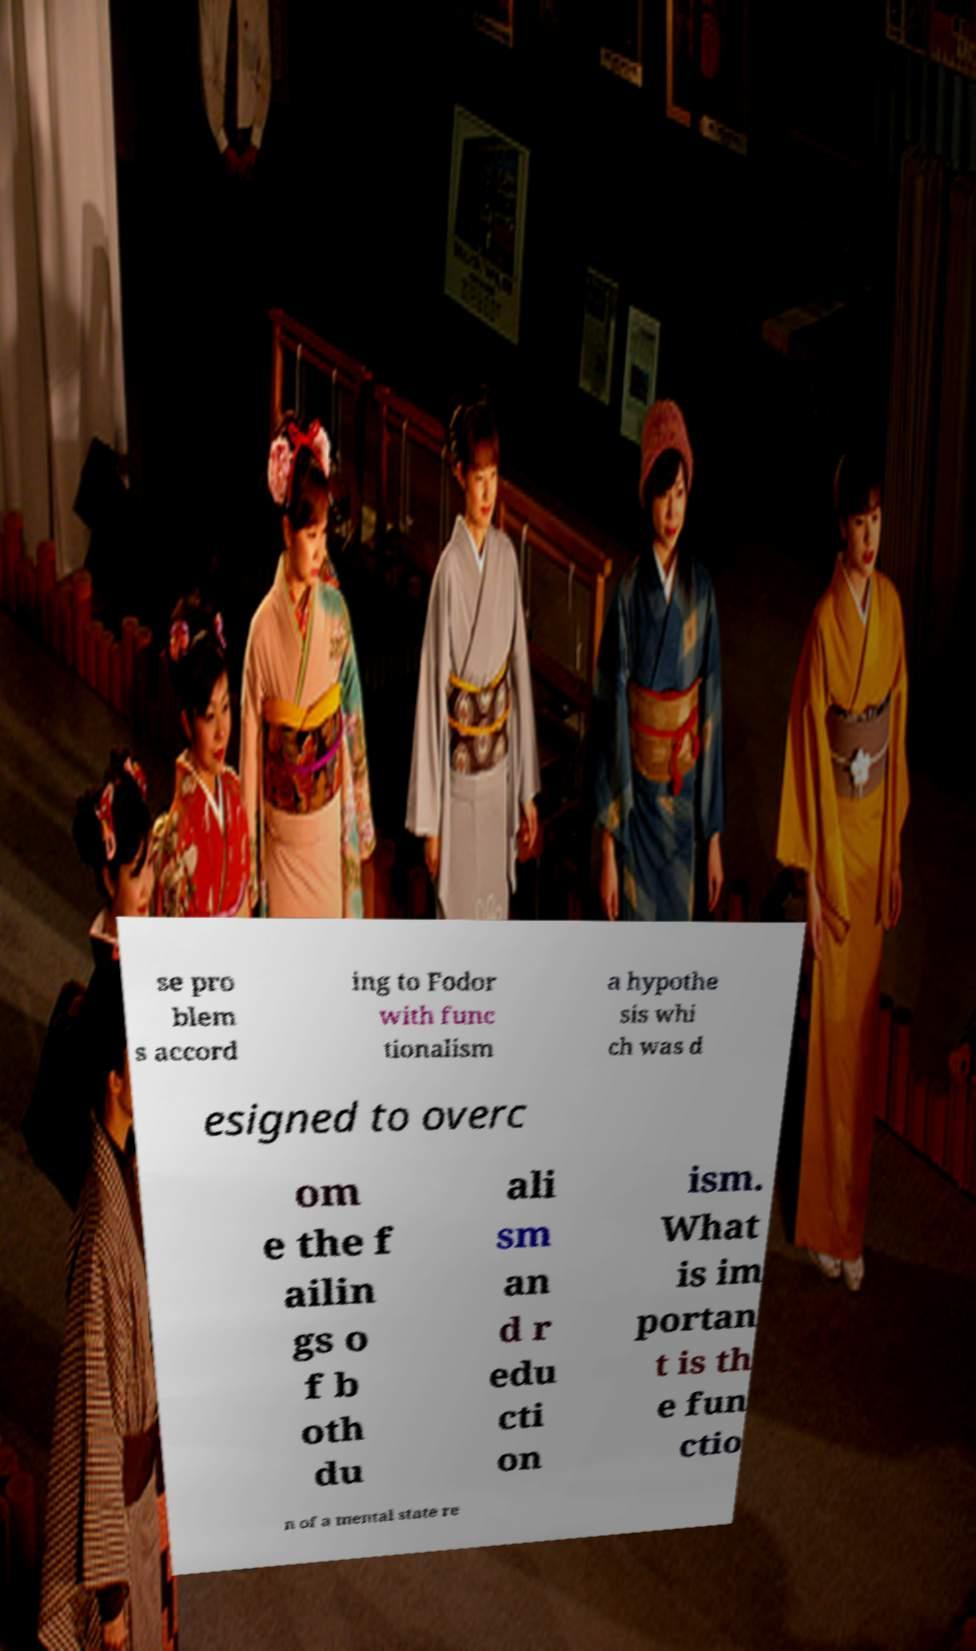Can you read and provide the text displayed in the image?This photo seems to have some interesting text. Can you extract and type it out for me? se pro blem s accord ing to Fodor with func tionalism a hypothe sis whi ch was d esigned to overc om e the f ailin gs o f b oth du ali sm an d r edu cti on ism. What is im portan t is th e fun ctio n of a mental state re 